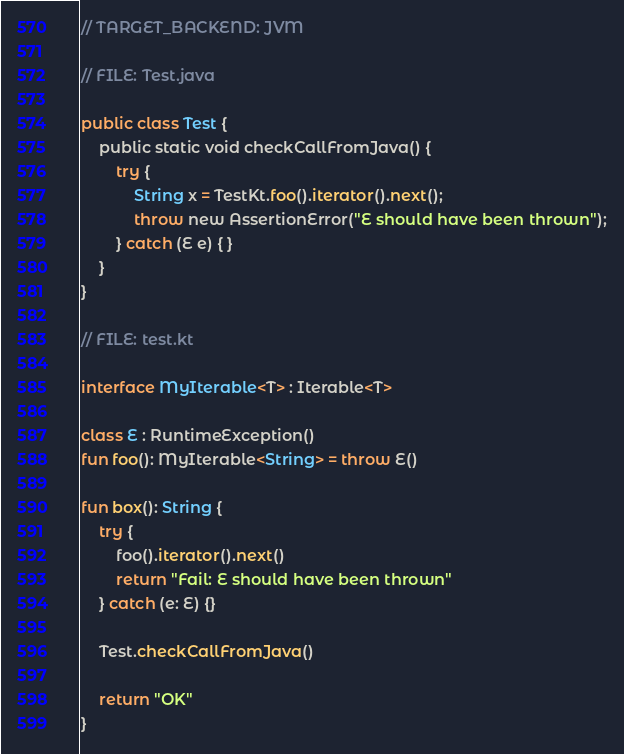<code> <loc_0><loc_0><loc_500><loc_500><_Kotlin_>// TARGET_BACKEND: JVM

// FILE: Test.java

public class Test {
    public static void checkCallFromJava() {
        try {
            String x = TestKt.foo().iterator().next();
            throw new AssertionError("E should have been thrown");
        } catch (E e) { }
    }
}

// FILE: test.kt

interface MyIterable<T> : Iterable<T>

class E : RuntimeException()
fun foo(): MyIterable<String> = throw E()

fun box(): String {
    try {
        foo().iterator().next()
        return "Fail: E should have been thrown"
    } catch (e: E) {}

    Test.checkCallFromJava()

    return "OK"
}
</code> 